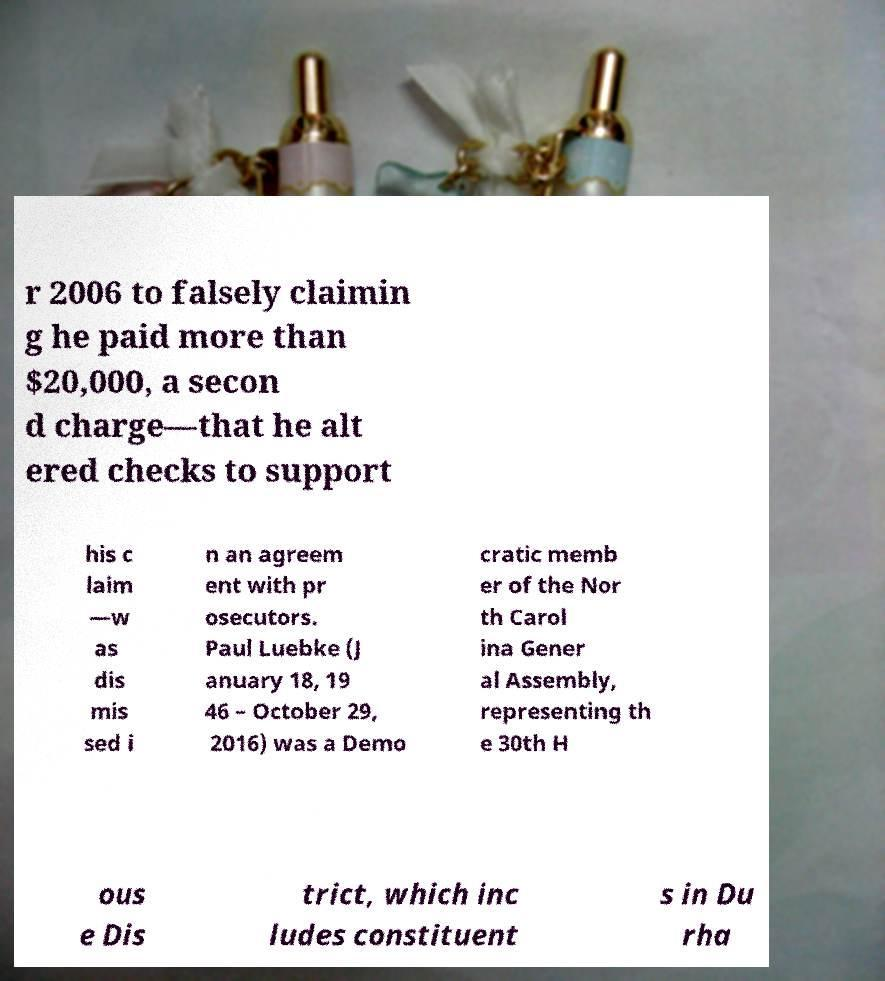For documentation purposes, I need the text within this image transcribed. Could you provide that? r 2006 to falsely claimin g he paid more than $20,000, a secon d charge—that he alt ered checks to support his c laim —w as dis mis sed i n an agreem ent with pr osecutors. Paul Luebke (J anuary 18, 19 46 – October 29, 2016) was a Demo cratic memb er of the Nor th Carol ina Gener al Assembly, representing th e 30th H ous e Dis trict, which inc ludes constituent s in Du rha 